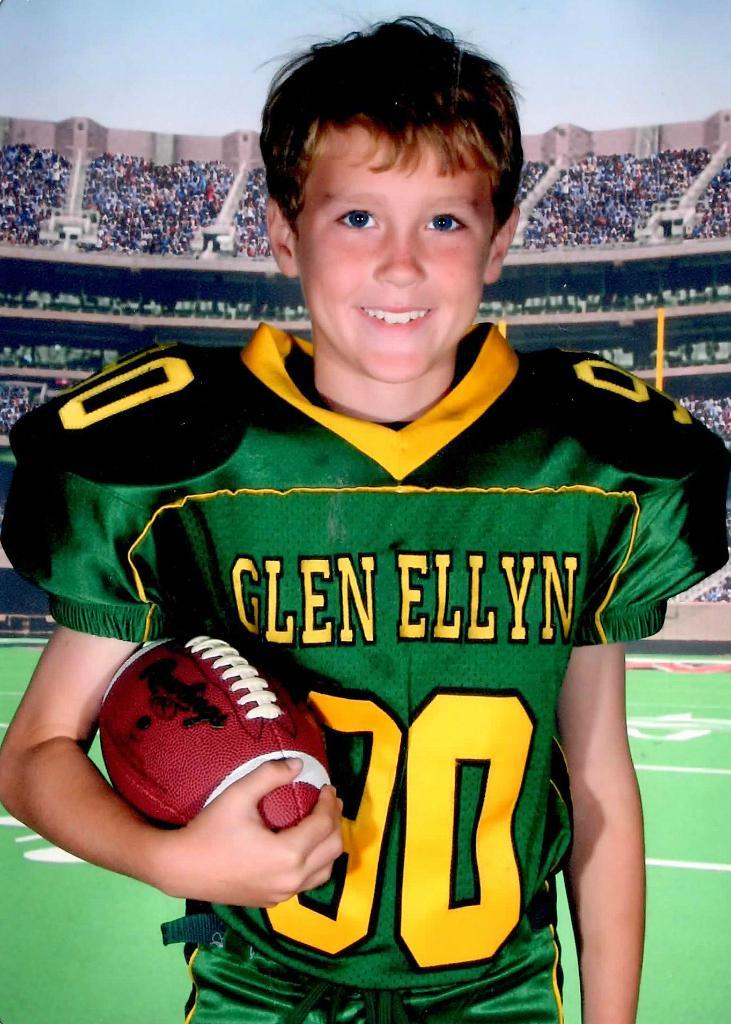What is the football teams name?
Offer a very short reply. Glen ellyn. What number is the player?
Your response must be concise. 80. 